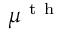<formula> <loc_0><loc_0><loc_500><loc_500>\mu ^ { t h }</formula> 